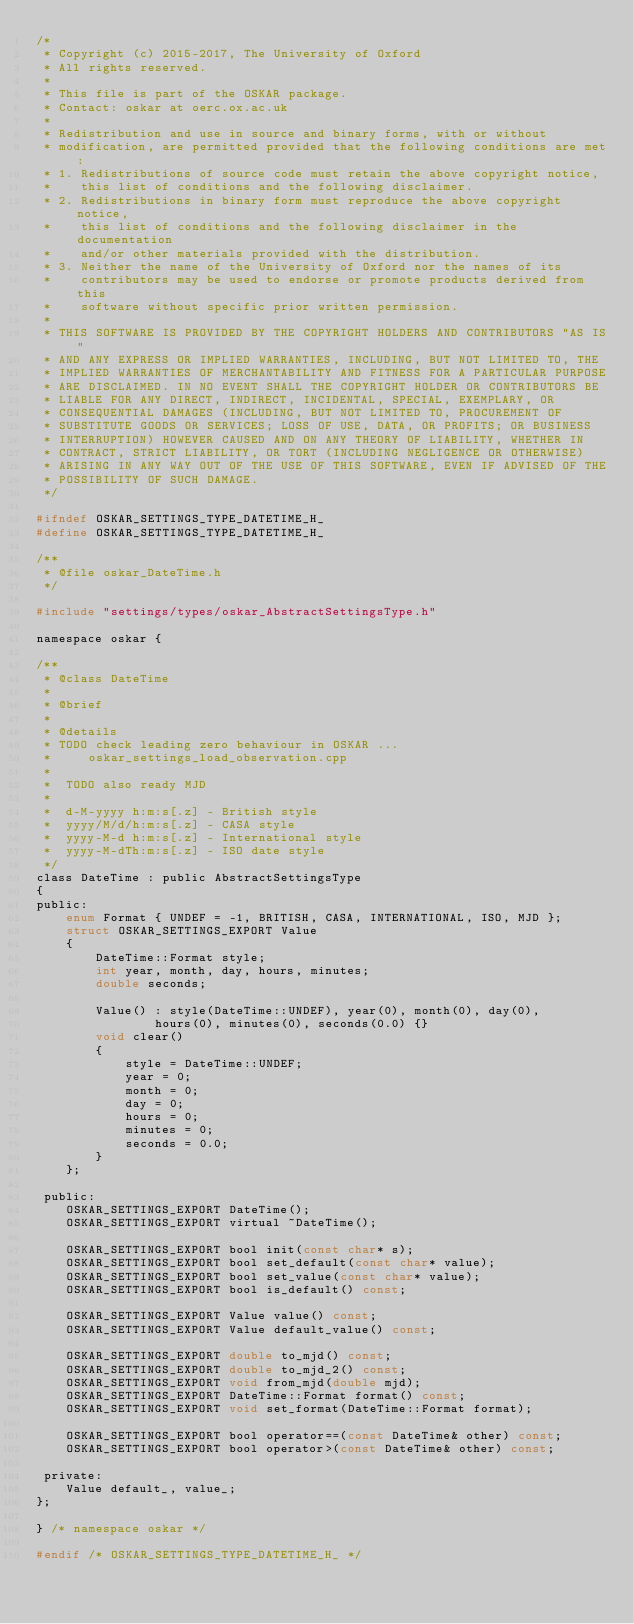<code> <loc_0><loc_0><loc_500><loc_500><_C_>/*
 * Copyright (c) 2015-2017, The University of Oxford
 * All rights reserved.
 *
 * This file is part of the OSKAR package.
 * Contact: oskar at oerc.ox.ac.uk
 *
 * Redistribution and use in source and binary forms, with or without
 * modification, are permitted provided that the following conditions are met:
 * 1. Redistributions of source code must retain the above copyright notice,
 *    this list of conditions and the following disclaimer.
 * 2. Redistributions in binary form must reproduce the above copyright notice,
 *    this list of conditions and the following disclaimer in the documentation
 *    and/or other materials provided with the distribution.
 * 3. Neither the name of the University of Oxford nor the names of its
 *    contributors may be used to endorse or promote products derived from this
 *    software without specific prior written permission.
 *
 * THIS SOFTWARE IS PROVIDED BY THE COPYRIGHT HOLDERS AND CONTRIBUTORS "AS IS"
 * AND ANY EXPRESS OR IMPLIED WARRANTIES, INCLUDING, BUT NOT LIMITED TO, THE
 * IMPLIED WARRANTIES OF MERCHANTABILITY AND FITNESS FOR A PARTICULAR PURPOSE
 * ARE DISCLAIMED. IN NO EVENT SHALL THE COPYRIGHT HOLDER OR CONTRIBUTORS BE
 * LIABLE FOR ANY DIRECT, INDIRECT, INCIDENTAL, SPECIAL, EXEMPLARY, OR
 * CONSEQUENTIAL DAMAGES (INCLUDING, BUT NOT LIMITED TO, PROCUREMENT OF
 * SUBSTITUTE GOODS OR SERVICES; LOSS OF USE, DATA, OR PROFITS; OR BUSINESS
 * INTERRUPTION) HOWEVER CAUSED AND ON ANY THEORY OF LIABILITY, WHETHER IN
 * CONTRACT, STRICT LIABILITY, OR TORT (INCLUDING NEGLIGENCE OR OTHERWISE)
 * ARISING IN ANY WAY OUT OF THE USE OF THIS SOFTWARE, EVEN IF ADVISED OF THE
 * POSSIBILITY OF SUCH DAMAGE.
 */

#ifndef OSKAR_SETTINGS_TYPE_DATETIME_H_
#define OSKAR_SETTINGS_TYPE_DATETIME_H_

/**
 * @file oskar_DateTime.h
 */

#include "settings/types/oskar_AbstractSettingsType.h"

namespace oskar {

/**
 * @class DateTime
 *
 * @brief
 *
 * @details
 * TODO check leading zero behaviour in OSKAR ...
 *     oskar_settings_load_observation.cpp
 *
 *  TODO also ready MJD
 *
 *  d-M-yyyy h:m:s[.z] - British style
 *  yyyy/M/d/h:m:s[.z] - CASA style
 *  yyyy-M-d h:m:s[.z] - International style
 *  yyyy-M-dTh:m:s[.z] - ISO date style
 */
class DateTime : public AbstractSettingsType
{
public:
    enum Format { UNDEF = -1, BRITISH, CASA, INTERNATIONAL, ISO, MJD };
    struct OSKAR_SETTINGS_EXPORT Value
    {
        DateTime::Format style;
        int year, month, day, hours, minutes;
        double seconds;

        Value() : style(DateTime::UNDEF), year(0), month(0), day(0),
                hours(0), minutes(0), seconds(0.0) {}
        void clear()
        {
            style = DateTime::UNDEF;
            year = 0;
            month = 0;
            day = 0;
            hours = 0;
            minutes = 0;
            seconds = 0.0;
        }
    };

 public:
    OSKAR_SETTINGS_EXPORT DateTime();
    OSKAR_SETTINGS_EXPORT virtual ~DateTime();

    OSKAR_SETTINGS_EXPORT bool init(const char* s);
    OSKAR_SETTINGS_EXPORT bool set_default(const char* value);
    OSKAR_SETTINGS_EXPORT bool set_value(const char* value);
    OSKAR_SETTINGS_EXPORT bool is_default() const;

    OSKAR_SETTINGS_EXPORT Value value() const;
    OSKAR_SETTINGS_EXPORT Value default_value() const;

    OSKAR_SETTINGS_EXPORT double to_mjd() const;
    OSKAR_SETTINGS_EXPORT double to_mjd_2() const;
    OSKAR_SETTINGS_EXPORT void from_mjd(double mjd);
    OSKAR_SETTINGS_EXPORT DateTime::Format format() const;
    OSKAR_SETTINGS_EXPORT void set_format(DateTime::Format format);

    OSKAR_SETTINGS_EXPORT bool operator==(const DateTime& other) const;
    OSKAR_SETTINGS_EXPORT bool operator>(const DateTime& other) const;

 private:
    Value default_, value_;
};

} /* namespace oskar */

#endif /* OSKAR_SETTINGS_TYPE_DATETIME_H_ */
</code> 